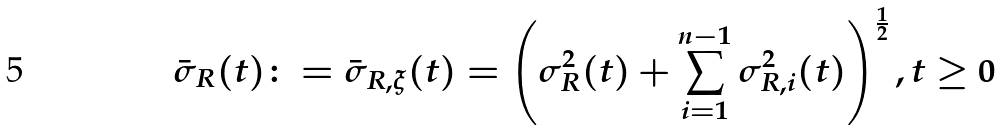Convert formula to latex. <formula><loc_0><loc_0><loc_500><loc_500>\bar { \sigma } _ { R } ( t ) \colon = \bar { \sigma } _ { R , \xi } ( t ) = \left ( \sigma _ { R } ^ { 2 } ( t ) + \sum _ { i = 1 } ^ { n - 1 } \sigma _ { R , i } ^ { 2 } ( t ) \right ) ^ { \frac { 1 } { 2 } } , t \geq 0</formula> 